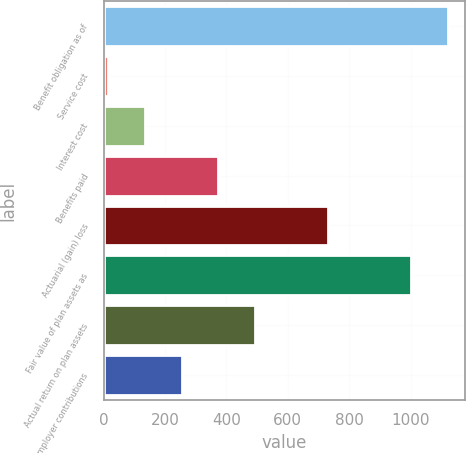Convert chart to OTSL. <chart><loc_0><loc_0><loc_500><loc_500><bar_chart><fcel>Benefit obligation as of<fcel>Service cost<fcel>Interest cost<fcel>Benefits paid<fcel>Actuarial (gain) loss<fcel>Fair value of plan assets as<fcel>Actual return on plan assets<fcel>Employer contributions<nl><fcel>1121.8<fcel>16<fcel>135.4<fcel>374.2<fcel>732.4<fcel>1002.4<fcel>493.6<fcel>254.8<nl></chart> 